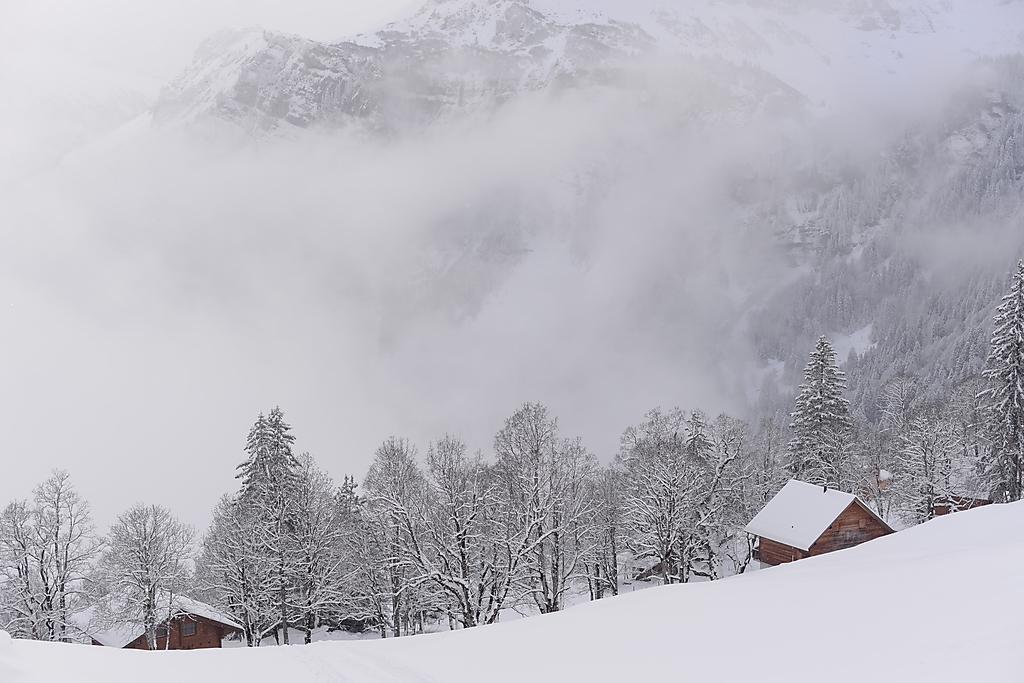In one or two sentences, can you explain what this image depicts? This picture is taken from outside of the city. In this image, on the right side, we can see a house which is filled with snow. On the left side, we can also see another house which is filled with snow. In the background, we can some trees and plants which are filled with snow. In the background, we can see some mountains. At the bottom, we can see a snow. 